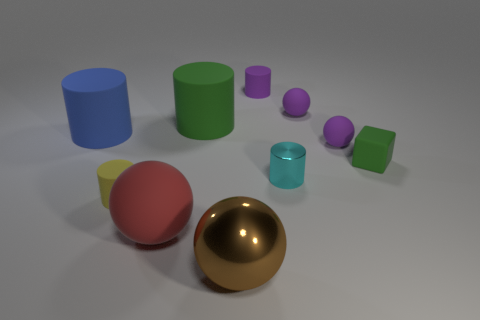Does the image seem to represent a real-life situation or is it more abstract? This image seems more abstract and likely created as a 3D rendering to illustrate different shapes and colors. It doesn't appear to represent a real-life situation but rather serves as a visual exercise in geometry and color theory. 